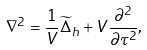<formula> <loc_0><loc_0><loc_500><loc_500>\nabla ^ { 2 } = \frac { 1 } { V } \widetilde { \Delta } _ { h } + V \frac { \partial ^ { 2 } } { \partial \tau ^ { 2 } } ,</formula> 